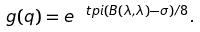<formula> <loc_0><loc_0><loc_500><loc_500>g ( q ) = e ^ { \ t p i ( B ( \lambda , \lambda ) - \sigma ) / 8 } .</formula> 